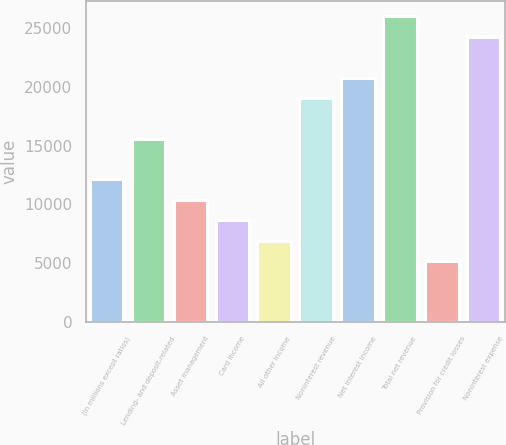<chart> <loc_0><loc_0><loc_500><loc_500><bar_chart><fcel>(in millions except ratios)<fcel>Lending- and deposit-related<fcel>Asset management<fcel>Card income<fcel>All other income<fcel>Noninterest revenue<fcel>Net interest income<fcel>Total net revenue<fcel>Provision for credit losses<fcel>Noninterest expense<nl><fcel>12124.8<fcel>15581.6<fcel>10396.4<fcel>8668<fcel>6939.6<fcel>19038.4<fcel>20766.8<fcel>25952<fcel>5211.2<fcel>24223.6<nl></chart> 